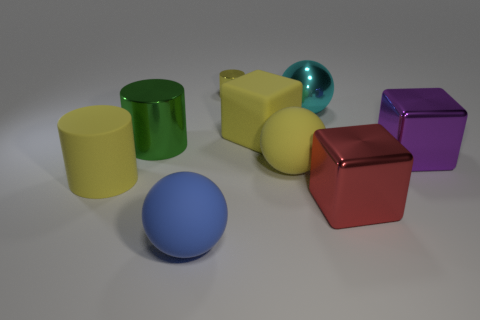Add 1 tiny yellow objects. How many objects exist? 10 Subtract all spheres. How many objects are left? 6 Add 6 metallic balls. How many metallic balls are left? 7 Add 3 green rubber things. How many green rubber things exist? 3 Subtract 0 blue cylinders. How many objects are left? 9 Subtract all small brown objects. Subtract all big red metal things. How many objects are left? 8 